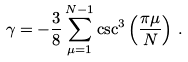Convert formula to latex. <formula><loc_0><loc_0><loc_500><loc_500>\gamma = - \frac { 3 } { 8 } \sum _ { \mu = 1 } ^ { N - 1 } \csc ^ { 3 } \left ( \frac { \pi \mu } { N } \right ) \, .</formula> 